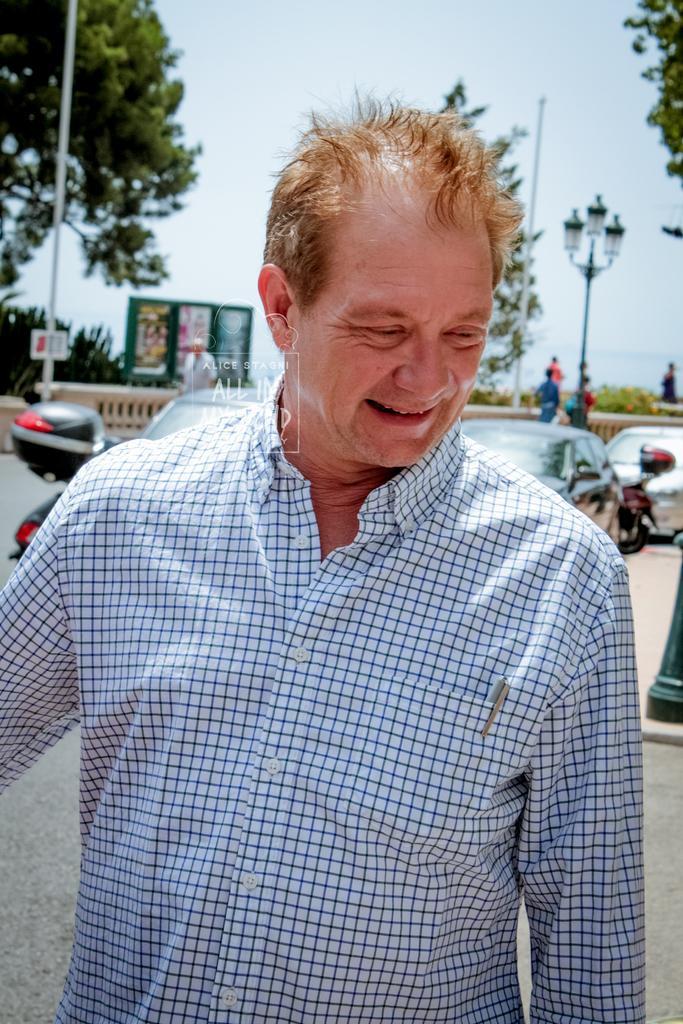In one or two sentences, can you explain what this image depicts? In this image there is a man standing on a road, in the background there are vehicles, people, light poles, trees and the sky and it is blurred, in the middle there is a watermark. 